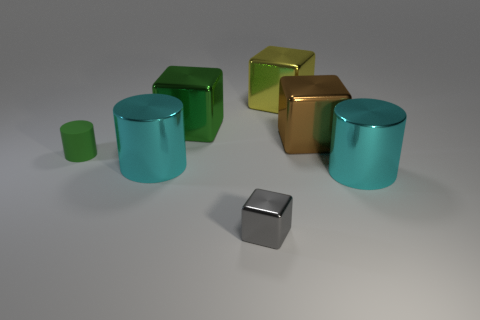What time of day do you think this image was captured? Given the controlled lighting and lack of natural light indicators, it’s likely that this is a staged scene and the concept of 'time of day' is not applicable. 